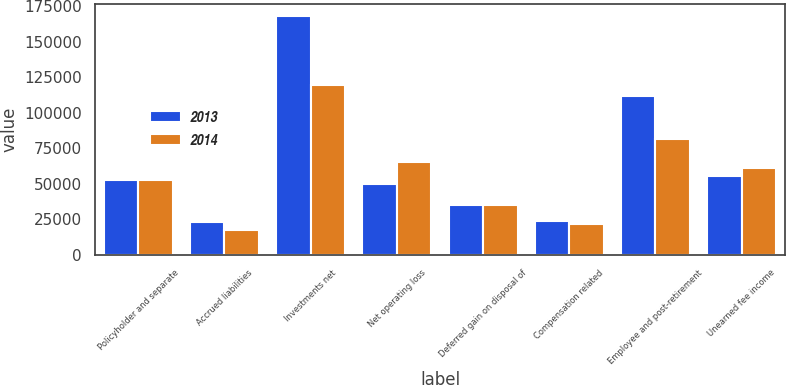Convert chart to OTSL. <chart><loc_0><loc_0><loc_500><loc_500><stacked_bar_chart><ecel><fcel>Policyholder and separate<fcel>Accrued liabilities<fcel>Investments net<fcel>Net operating loss<fcel>Deferred gain on disposal of<fcel>Compensation related<fcel>Employee and post-retirement<fcel>Unearned fee income<nl><fcel>2013<fcel>52934<fcel>23183<fcel>168061<fcel>50103<fcel>35347<fcel>24029<fcel>111716<fcel>55765<nl><fcel>2014<fcel>52934<fcel>17791<fcel>119410<fcel>65507<fcel>34833<fcel>21713<fcel>81725<fcel>61121<nl></chart> 